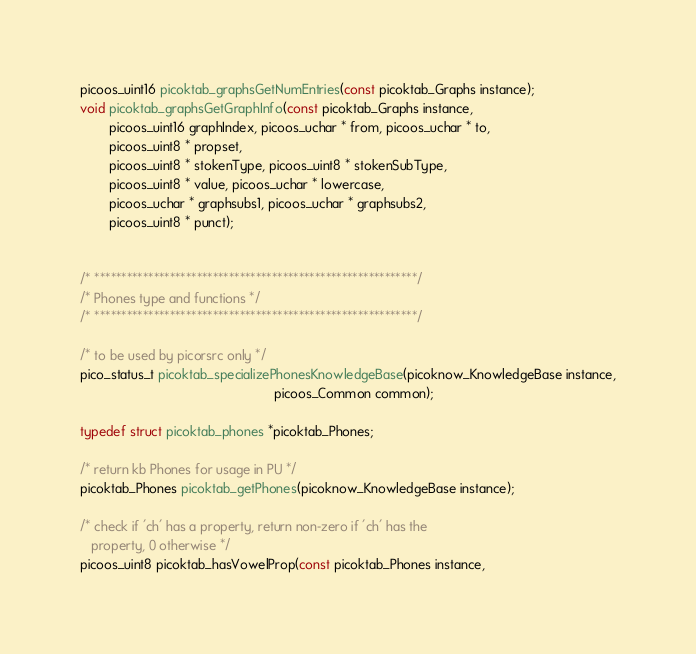Convert code to text. <code><loc_0><loc_0><loc_500><loc_500><_C_>
picoos_uint16 picoktab_graphsGetNumEntries(const picoktab_Graphs instance);
void picoktab_graphsGetGraphInfo(const picoktab_Graphs instance,
        picoos_uint16 graphIndex, picoos_uchar * from, picoos_uchar * to,
        picoos_uint8 * propset,
        picoos_uint8 * stokenType, picoos_uint8 * stokenSubType,
        picoos_uint8 * value, picoos_uchar * lowercase,
        picoos_uchar * graphsubs1, picoos_uchar * graphsubs2,
        picoos_uint8 * punct);


/* ************************************************************/
/* Phones type and functions */
/* ************************************************************/

/* to be used by picorsrc only */
pico_status_t picoktab_specializePhonesKnowledgeBase(picoknow_KnowledgeBase instance,
                                                     picoos_Common common);

typedef struct picoktab_phones *picoktab_Phones;

/* return kb Phones for usage in PU */
picoktab_Phones picoktab_getPhones(picoknow_KnowledgeBase instance);

/* check if 'ch' has a property, return non-zero if 'ch' has the
   property, 0 otherwise */
picoos_uint8 picoktab_hasVowelProp(const picoktab_Phones instance,</code> 